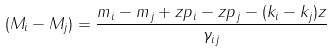<formula> <loc_0><loc_0><loc_500><loc_500>( M _ { i } - M _ { j } ) = \frac { m _ { i } - m _ { j } + z p _ { i } - z p _ { j } - ( k _ { i } - k _ { j } ) z } { \gamma _ { i j } }</formula> 